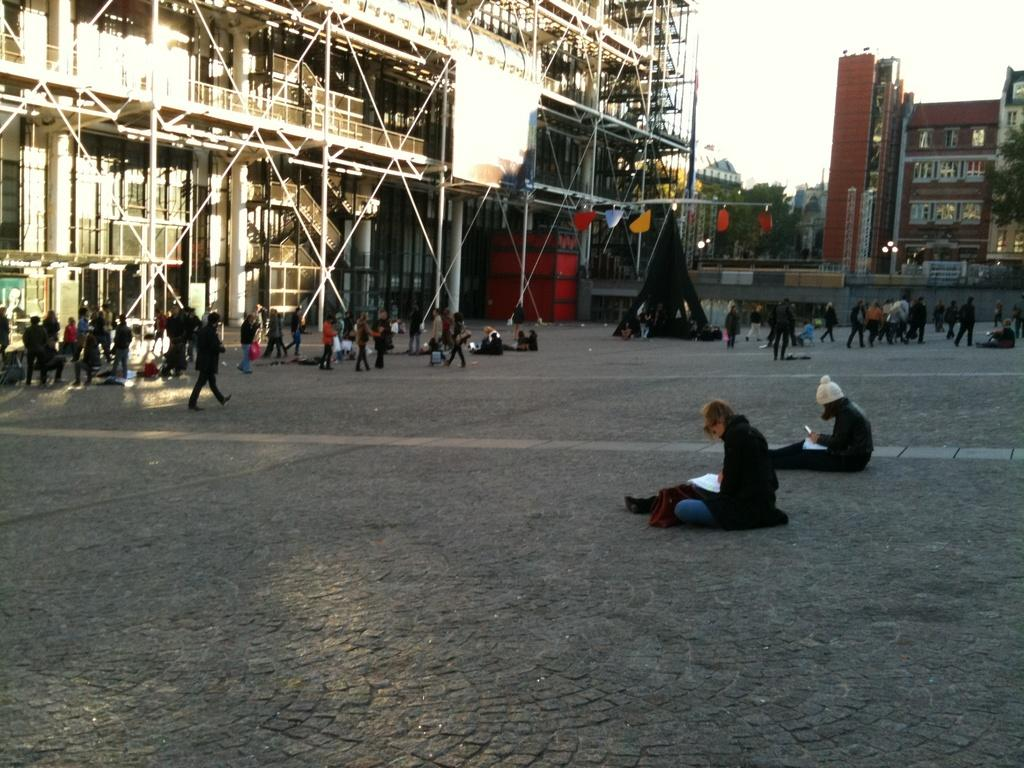How many people are in the image? There is a group of people in the image, but the exact number cannot be determined from the provided facts. What type of structure is visible in the image? There is a building in the image. What other natural elements can be seen in the image? There are trees in the image. What type of illumination is present in the image? There are lights in the image. What architectural feature is present in the image? There is a wall in the image. What surface is visible in the image? There is a ground in the image. What type of stove is being used by the queen in the image? There is no queen or stove present in the image. 